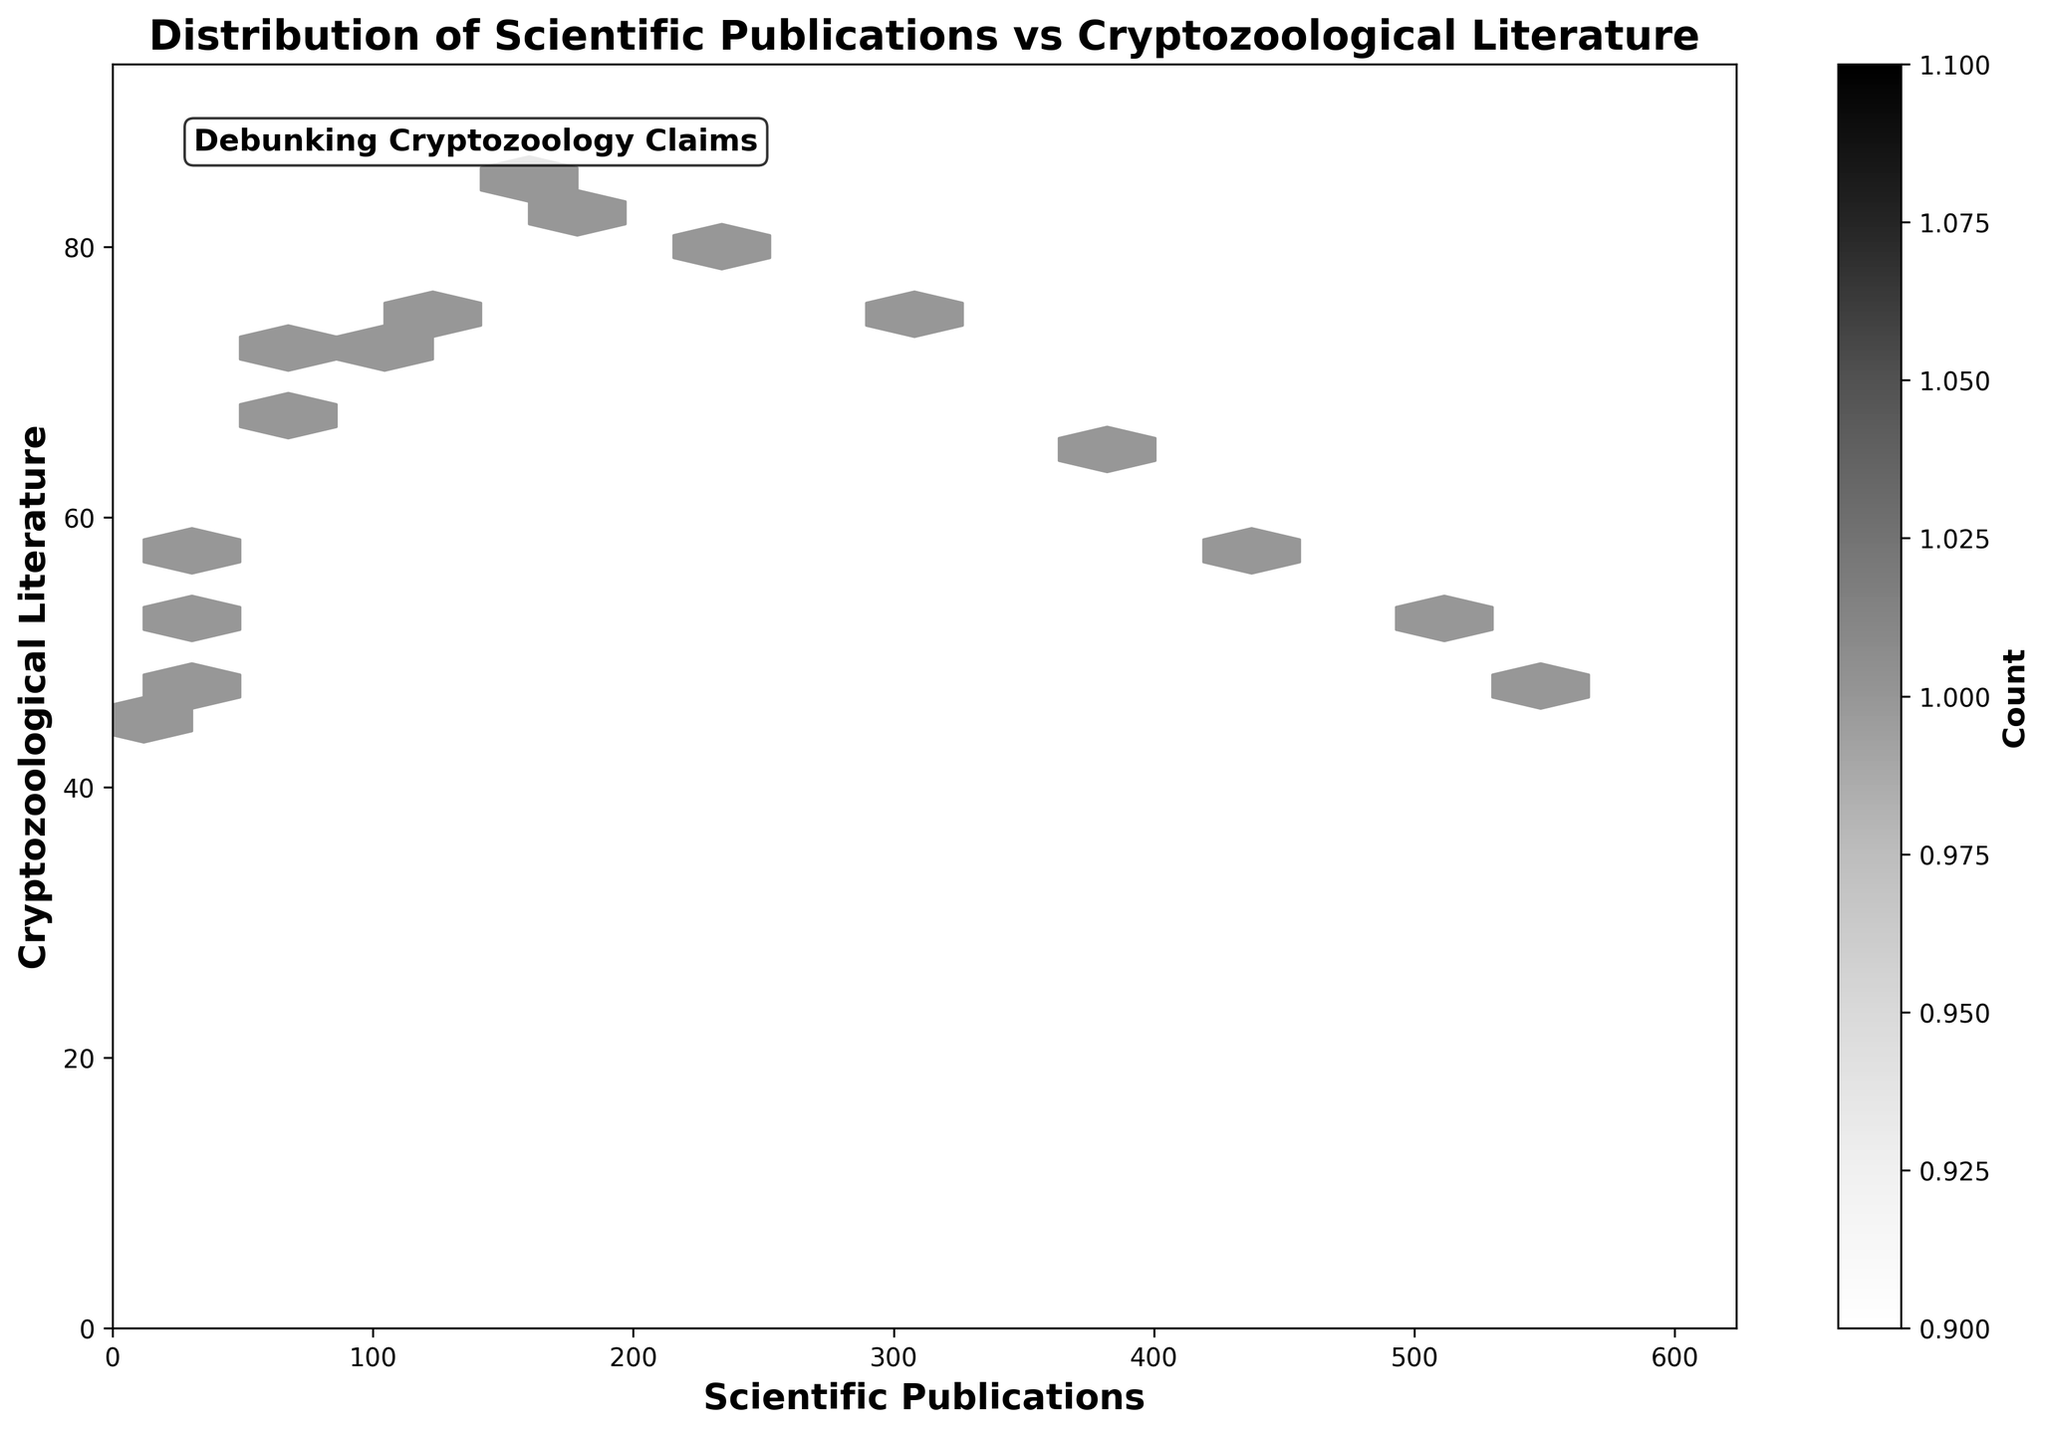What's the title of the figure? The title is displayed at the top of the plot. From the provided code, we know it is clearly written as "Distribution of Scientific Publications vs Cryptozoological Literature."
Answer: Distribution of Scientific Publications vs Cryptozoological Literature What do the axes represent? The x-axis label is "Scientific Publications," and the y-axis label is "Cryptozoological Literature." These labels are specified in the code and should be clearly visible in the figure.
Answer: The x-axis represents Scientific Publications and the y-axis represents Cryptozoological Literature What color scheme is used in the hexbin plot? The color scheme used is a grayscale palette, as specified by the 'Greys' colormap in the provided code.
Answer: Grayscale Where is the highest density of points located in the plot? The highest density area can be found where the hexagons are the darkest. Based on the given data, this would likely be around (378, 64) and (512, 51) as they correspond to higher scientific publications with less cryptozoological literature.
Answer: Around (378, 64) and (512, 51) How does the count change in the color bar indicate the density? The color bar shows a gradient from light to dark, where a dark shade indicates a higher count or density of overlapping points.
Answer: Darker hexagons indicate higher density How many data points fall within the 300 to 500 range for scientific publications? To determine this, observe the x-axis range of 300 to 500 and count the number of hexagons that fall within this range. The prominent points in this range are 378, 442, and 512, adding three data points.
Answer: 3 Which year has the maximum number of scientific publications? From the data, we see the year 2022 has the highest number of scientific publications, with a count of 567.
Answer: 2022 Comparing the years 1980 and 2000, which had higher cryptozoological literature? Looking at the data, 1980 had 73, whereas 2000 had 79. Therefore, 2000 had higher cryptozoological literature.
Answer: 2000 What trend can be observed in the relationship between scientific publications and cryptozoological literature over time? Over time, there is a clear increase in scientific publications, while cryptozoological literature shows a peak and then gradually declines. This suggests rising interest and discovery in valid scientific topics outpacing cryptozoological studies.
Answer: Increasing scientific publications and plateauing then declining cryptozoological literature What might be the reason for the text “Debunking Cryptozoology Claims” included in the plot? This statement indicates an additional message that the figure aims to highlight the disparity and to reinforce the preference for scientific validation over cryptozoological claims.
Answer: Highlighting disparity and reinforcing scientific validation over cryptozoological claims 